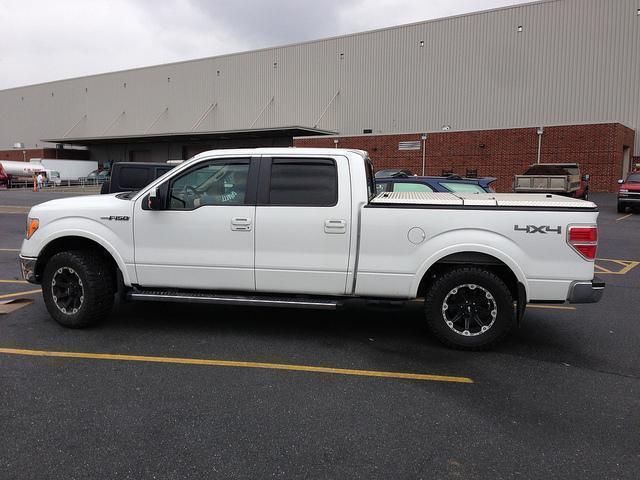What is the answer to the equation on the side of the truck?
From the following four choices, select the correct answer to address the question.
Options: 72, 24, 16, 89. 16. What would the answer to the equation on the truck be if the x is replaced by a sign?
From the following four choices, select the correct answer to address the question.
Options: 12, eight, zero, ten. Eight. 